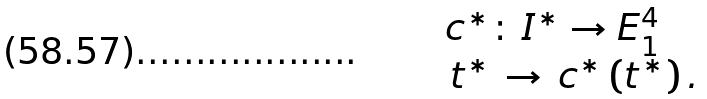<formula> <loc_0><loc_0><loc_500><loc_500>\begin{array} { l } { { c } ^ { * } } \colon \, { I ^ { * } } \to E _ { 1 } ^ { 4 } \\ \, { t ^ { * } } \, \to \, { { c } ^ { * } } \left ( { t ^ { * } } \right ) . \\ \end{array}</formula> 